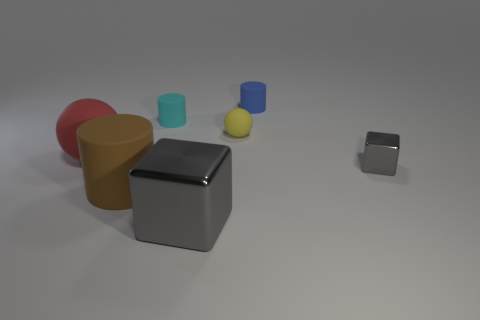What number of objects are gray things that are in front of the tiny metal object or things behind the red rubber thing?
Provide a short and direct response. 4. What number of other things are there of the same size as the yellow matte object?
Offer a terse response. 3. There is a block that is behind the large gray object; does it have the same color as the large metal thing?
Give a very brief answer. Yes. What size is the thing that is both on the left side of the large gray object and in front of the large ball?
Provide a short and direct response. Large. What number of big things are either brown matte spheres or rubber cylinders?
Your response must be concise. 1. There is a metallic object left of the yellow thing; what is its shape?
Provide a succinct answer. Cube. How many gray cubes are there?
Make the answer very short. 2. Are the tiny blue object and the tiny cyan thing made of the same material?
Provide a short and direct response. Yes. Is the number of matte cylinders that are behind the small gray metal thing greater than the number of small balls?
Your answer should be very brief. Yes. What number of objects are either cylinders or objects in front of the big matte ball?
Your answer should be compact. 5. 